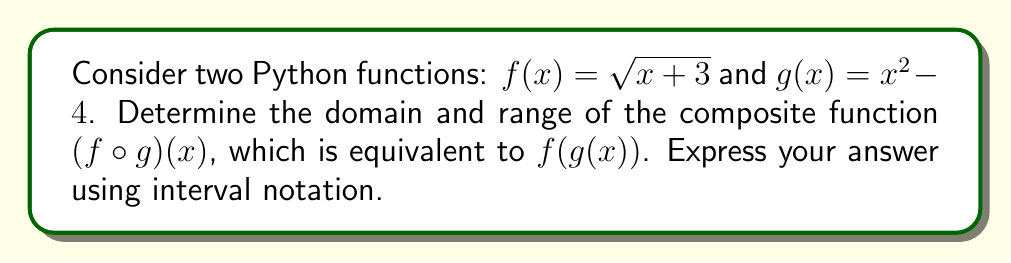Give your solution to this math problem. Let's approach this step-by-step:

1) First, we need to find the composite function $(f \circ g)(x)$:
   $$(f \circ g)(x) = f(g(x)) = \sqrt{g(x) + 3} = \sqrt{(x^2 - 4) + 3} = \sqrt{x^2 - 1}$$

2) Now, let's determine the domain:
   - For the square root to be defined, we need $x^2 - 1 \geq 0$
   - Solving this inequality: $x^2 \geq 1$
   - This is true when $x \leq -1$ or $x \geq 1$

3) For the range, let's consider the function $y = \sqrt{x^2 - 1}$:
   - The minimum value of $x^2 - 1$ is -1 (when $x = 0$), but our domain restricts $x$ to values where $x^2 - 1 \geq 0$
   - Therefore, the minimum value of $\sqrt{x^2 - 1}$ is 0
   - As $x$ approaches $\pm \infty$, $\sqrt{x^2 - 1}$ approaches $\infty$

4) In Python notation, we might express this composite function as:

   ```python
   def g(x):
       return x**2 - 4

   def f(x):
       return math.sqrt(x + 3)

   def composite(x):
       return f(g(x))
   ```

   The domain restriction would be implemented in the `composite` function to handle invalid inputs.
Answer: Domain: $(-\infty, -1] \cup [1, \infty)$, Range: $[0, \infty)$ 